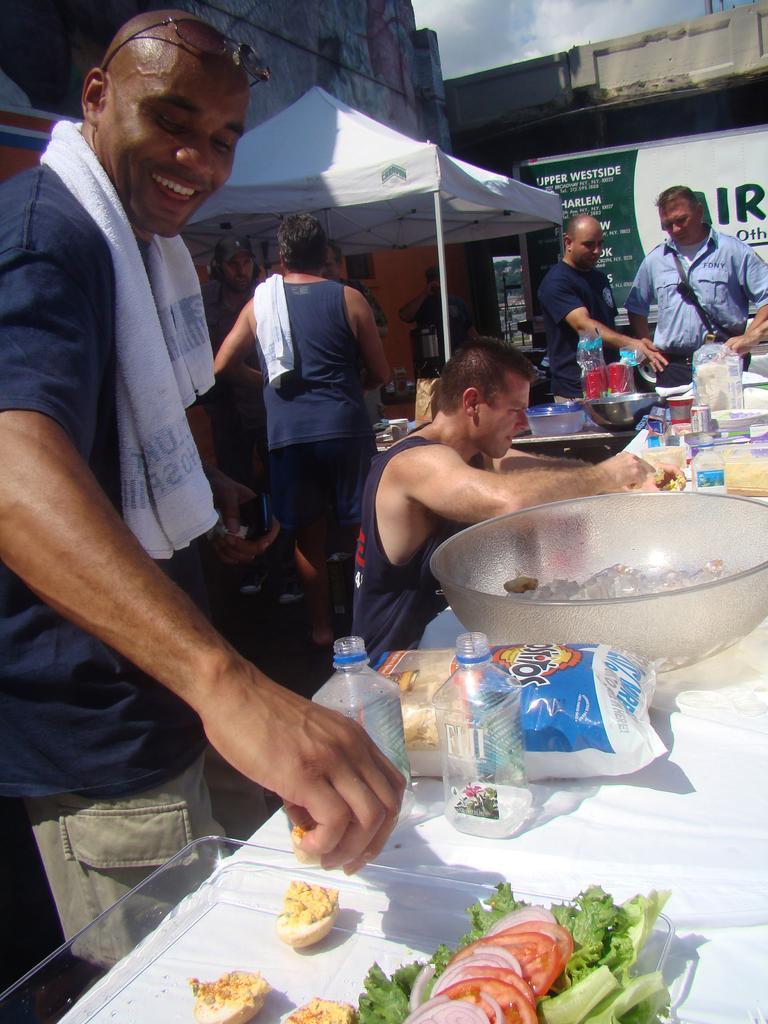Could you give a brief overview of what you see in this image? In this image there is a table on which there are glass bowls,bottles,packets and some food stuff. On the left side there is a person who is decorating the egg with the green leaves,tomatoes on it. In the background there is a tent on under which there are few people standing. At the top there is the sky. Behind the text there is a building. 